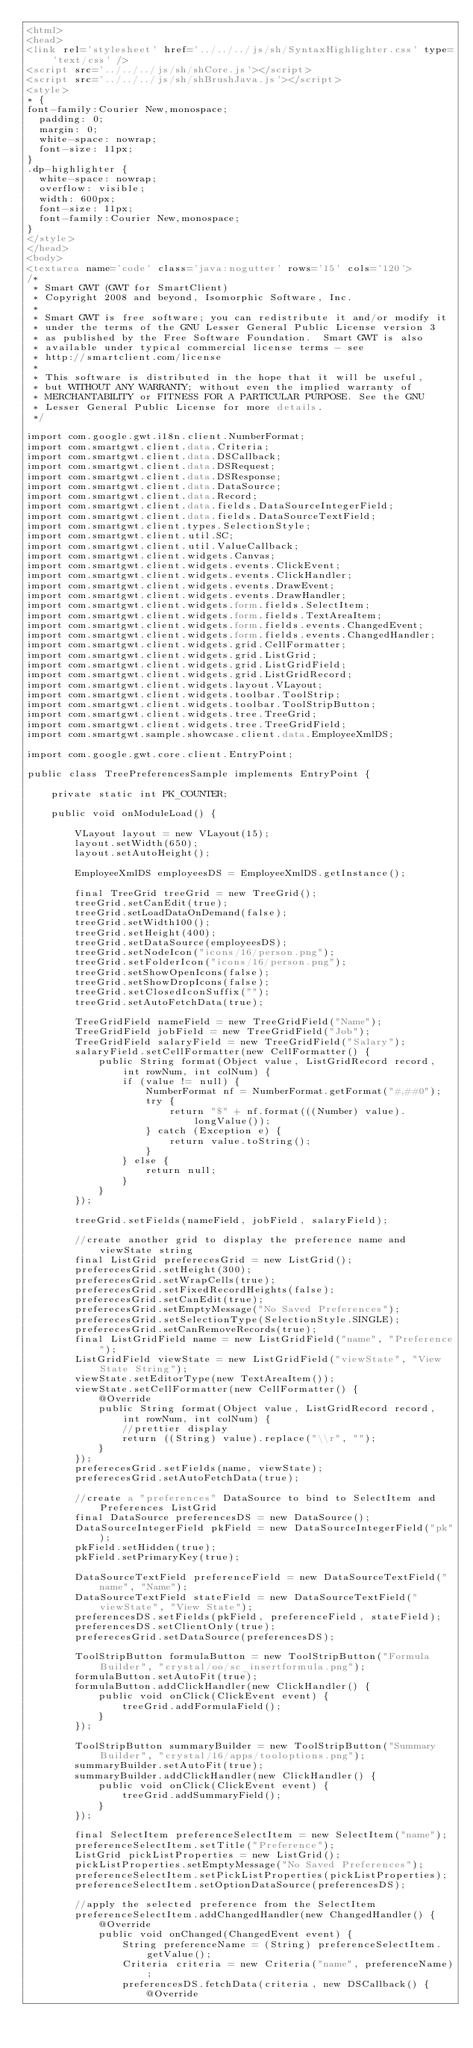Convert code to text. <code><loc_0><loc_0><loc_500><loc_500><_HTML_><html>
<head>
<link rel='stylesheet' href='../../../js/sh/SyntaxHighlighter.css' type='text/css' />
<script src='../../../js/sh/shCore.js'></script>
<script src='../../../js/sh/shBrushJava.js'></script>
<style>
* {
font-family:Courier New,monospace;
  padding: 0;
  margin: 0;
  white-space: nowrap;
  font-size: 11px;
}
.dp-highlighter {
  white-space: nowrap;
  overflow: visible;
  width: 600px;
  font-size: 11px;
  font-family:Courier New,monospace;
}
</style>
</head>
<body>
<textarea name='code' class='java:nogutter' rows='15' cols='120'>
/*
 * Smart GWT (GWT for SmartClient)
 * Copyright 2008 and beyond, Isomorphic Software, Inc.
 *
 * Smart GWT is free software; you can redistribute it and/or modify it
 * under the terms of the GNU Lesser General Public License version 3
 * as published by the Free Software Foundation.  Smart GWT is also
 * available under typical commercial license terms - see
 * http://smartclient.com/license
 *
 * This software is distributed in the hope that it will be useful,
 * but WITHOUT ANY WARRANTY; without even the implied warranty of
 * MERCHANTABILITY or FITNESS FOR A PARTICULAR PURPOSE. See the GNU
 * Lesser General Public License for more details.
 */

import com.google.gwt.i18n.client.NumberFormat;
import com.smartgwt.client.data.Criteria;
import com.smartgwt.client.data.DSCallback;
import com.smartgwt.client.data.DSRequest;
import com.smartgwt.client.data.DSResponse;
import com.smartgwt.client.data.DataSource;
import com.smartgwt.client.data.Record;
import com.smartgwt.client.data.fields.DataSourceIntegerField;
import com.smartgwt.client.data.fields.DataSourceTextField;
import com.smartgwt.client.types.SelectionStyle;
import com.smartgwt.client.util.SC;
import com.smartgwt.client.util.ValueCallback;
import com.smartgwt.client.widgets.Canvas;
import com.smartgwt.client.widgets.events.ClickEvent;
import com.smartgwt.client.widgets.events.ClickHandler;
import com.smartgwt.client.widgets.events.DrawEvent;
import com.smartgwt.client.widgets.events.DrawHandler;
import com.smartgwt.client.widgets.form.fields.SelectItem;
import com.smartgwt.client.widgets.form.fields.TextAreaItem;
import com.smartgwt.client.widgets.form.fields.events.ChangedEvent;
import com.smartgwt.client.widgets.form.fields.events.ChangedHandler;
import com.smartgwt.client.widgets.grid.CellFormatter;
import com.smartgwt.client.widgets.grid.ListGrid;
import com.smartgwt.client.widgets.grid.ListGridField;
import com.smartgwt.client.widgets.grid.ListGridRecord;
import com.smartgwt.client.widgets.layout.VLayout;
import com.smartgwt.client.widgets.toolbar.ToolStrip;
import com.smartgwt.client.widgets.toolbar.ToolStripButton;
import com.smartgwt.client.widgets.tree.TreeGrid;
import com.smartgwt.client.widgets.tree.TreeGridField;
import com.smartgwt.sample.showcase.client.data.EmployeeXmlDS;

import com.google.gwt.core.client.EntryPoint;

public class TreePreferencesSample implements EntryPoint {

    private static int PK_COUNTER;

    public void onModuleLoad() {

        VLayout layout = new VLayout(15);
        layout.setWidth(650);
        layout.setAutoHeight();

        EmployeeXmlDS employeesDS = EmployeeXmlDS.getInstance();

        final TreeGrid treeGrid = new TreeGrid();
        treeGrid.setCanEdit(true);
        treeGrid.setLoadDataOnDemand(false);
        treeGrid.setWidth100();
        treeGrid.setHeight(400);
        treeGrid.setDataSource(employeesDS);
        treeGrid.setNodeIcon("icons/16/person.png");
        treeGrid.setFolderIcon("icons/16/person.png");
        treeGrid.setShowOpenIcons(false);
        treeGrid.setShowDropIcons(false);
        treeGrid.setClosedIconSuffix("");
        treeGrid.setAutoFetchData(true);

        TreeGridField nameField = new TreeGridField("Name");
        TreeGridField jobField = new TreeGridField("Job");
        TreeGridField salaryField = new TreeGridField("Salary");
        salaryField.setCellFormatter(new CellFormatter() {
            public String format(Object value, ListGridRecord record, int rowNum, int colNum) {
                if (value != null) {
                    NumberFormat nf = NumberFormat.getFormat("#,##0");
                    try {
                        return "$" + nf.format(((Number) value).longValue());
                    } catch (Exception e) {
                        return value.toString();
                    }
                } else {
                    return null;
                }
            }
        });

        treeGrid.setFields(nameField, jobField, salaryField);

        //create another grid to display the preference name and viewState string
        final ListGrid preferecesGrid = new ListGrid();
        preferecesGrid.setHeight(300);
        preferecesGrid.setWrapCells(true);
        preferecesGrid.setFixedRecordHeights(false);
        preferecesGrid.setCanEdit(true);
        preferecesGrid.setEmptyMessage("No Saved Preferences");
        preferecesGrid.setSelectionType(SelectionStyle.SINGLE);
        preferecesGrid.setCanRemoveRecords(true);
        final ListGridField name = new ListGridField("name", "Preference");
        ListGridField viewState = new ListGridField("viewState", "View State String");
        viewState.setEditorType(new TextAreaItem());
        viewState.setCellFormatter(new CellFormatter() {
            @Override
            public String format(Object value, ListGridRecord record, int rowNum, int colNum) {
                //prettier display
                return ((String) value).replace("\\r", "");
            }
        });
        preferecesGrid.setFields(name, viewState);
        preferecesGrid.setAutoFetchData(true);

        //create a "preferences" DataSource to bind to SelectItem and Preferences ListGrid
        final DataSource preferencesDS = new DataSource();
        DataSourceIntegerField pkField = new DataSourceIntegerField("pk");
        pkField.setHidden(true);
        pkField.setPrimaryKey(true);

        DataSourceTextField preferenceField = new DataSourceTextField("name", "Name");
        DataSourceTextField stateField = new DataSourceTextField("viewState", "View State");
        preferencesDS.setFields(pkField, preferenceField, stateField);
        preferencesDS.setClientOnly(true);
        preferecesGrid.setDataSource(preferencesDS);

        ToolStripButton formulaButton = new ToolStripButton("Formula Builder", "crystal/oo/sc_insertformula.png");
        formulaButton.setAutoFit(true);
        formulaButton.addClickHandler(new ClickHandler() {
            public void onClick(ClickEvent event) {
                treeGrid.addFormulaField();
            }
        });

        ToolStripButton summaryBuilder = new ToolStripButton("Summary Builder", "crystal/16/apps/tooloptions.png");
        summaryBuilder.setAutoFit(true);
        summaryBuilder.addClickHandler(new ClickHandler() {
            public void onClick(ClickEvent event) {
                treeGrid.addSummaryField();
            }
        });

        final SelectItem preferenceSelectItem = new SelectItem("name");
        preferenceSelectItem.setTitle("Preference");
        ListGrid pickListProperties = new ListGrid();
        pickListProperties.setEmptyMessage("No Saved Preferences");
        preferenceSelectItem.setPickListProperties(pickListProperties);
        preferenceSelectItem.setOptionDataSource(preferencesDS);

        //apply the selected preference from the SelectItem
        preferenceSelectItem.addChangedHandler(new ChangedHandler() {
            @Override
            public void onChanged(ChangedEvent event) {
                String preferenceName = (String) preferenceSelectItem.getValue();
                Criteria criteria = new Criteria("name", preferenceName);
                preferencesDS.fetchData(criteria, new DSCallback() {
                    @Override</code> 